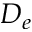Convert formula to latex. <formula><loc_0><loc_0><loc_500><loc_500>D _ { e }</formula> 